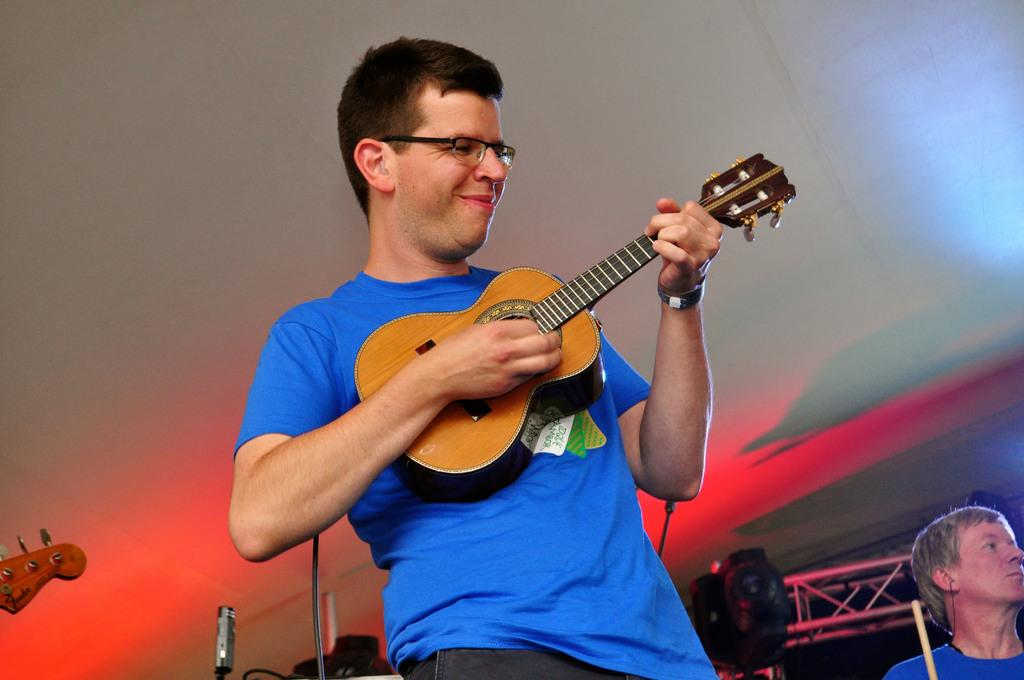What is the man in the image doing? The man is playing a guitar in the image. What can be seen on the man's face? The man is wearing spectacles in the image. Can you describe the background of the image? There is another person and a wall in the background of the image. What type of wing can be seen on the man's back in the image? There is no wing visible on the man's back in the image. How many corks are present in the image? There is no mention of corks in the image, so it is impossible to determine their presence or quantity. 